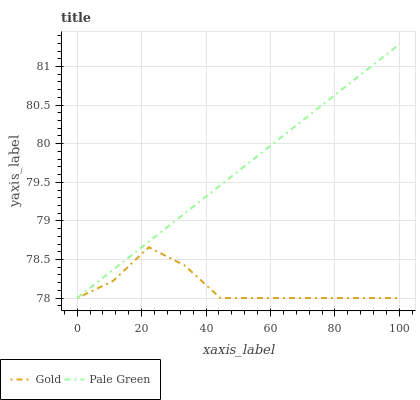Does Gold have the minimum area under the curve?
Answer yes or no. Yes. Does Pale Green have the maximum area under the curve?
Answer yes or no. Yes. Does Gold have the maximum area under the curve?
Answer yes or no. No. Is Pale Green the smoothest?
Answer yes or no. Yes. Is Gold the roughest?
Answer yes or no. Yes. Is Gold the smoothest?
Answer yes or no. No. Does Pale Green have the lowest value?
Answer yes or no. Yes. Does Pale Green have the highest value?
Answer yes or no. Yes. Does Gold have the highest value?
Answer yes or no. No. Does Gold intersect Pale Green?
Answer yes or no. Yes. Is Gold less than Pale Green?
Answer yes or no. No. Is Gold greater than Pale Green?
Answer yes or no. No. 